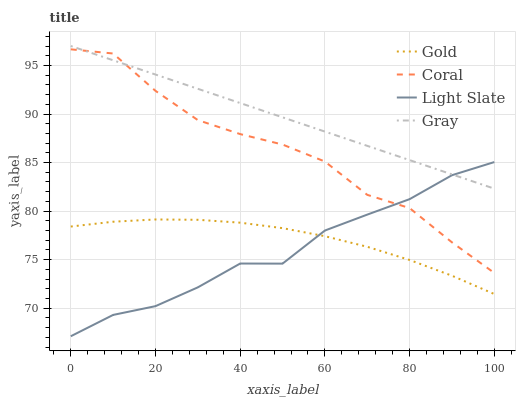Does Light Slate have the minimum area under the curve?
Answer yes or no. Yes. Does Gray have the maximum area under the curve?
Answer yes or no. Yes. Does Coral have the minimum area under the curve?
Answer yes or no. No. Does Coral have the maximum area under the curve?
Answer yes or no. No. Is Gray the smoothest?
Answer yes or no. Yes. Is Coral the roughest?
Answer yes or no. Yes. Is Coral the smoothest?
Answer yes or no. No. Is Gray the roughest?
Answer yes or no. No. Does Light Slate have the lowest value?
Answer yes or no. Yes. Does Coral have the lowest value?
Answer yes or no. No. Does Gray have the highest value?
Answer yes or no. Yes. Does Coral have the highest value?
Answer yes or no. No. Is Gold less than Gray?
Answer yes or no. Yes. Is Gray greater than Gold?
Answer yes or no. Yes. Does Light Slate intersect Coral?
Answer yes or no. Yes. Is Light Slate less than Coral?
Answer yes or no. No. Is Light Slate greater than Coral?
Answer yes or no. No. Does Gold intersect Gray?
Answer yes or no. No. 